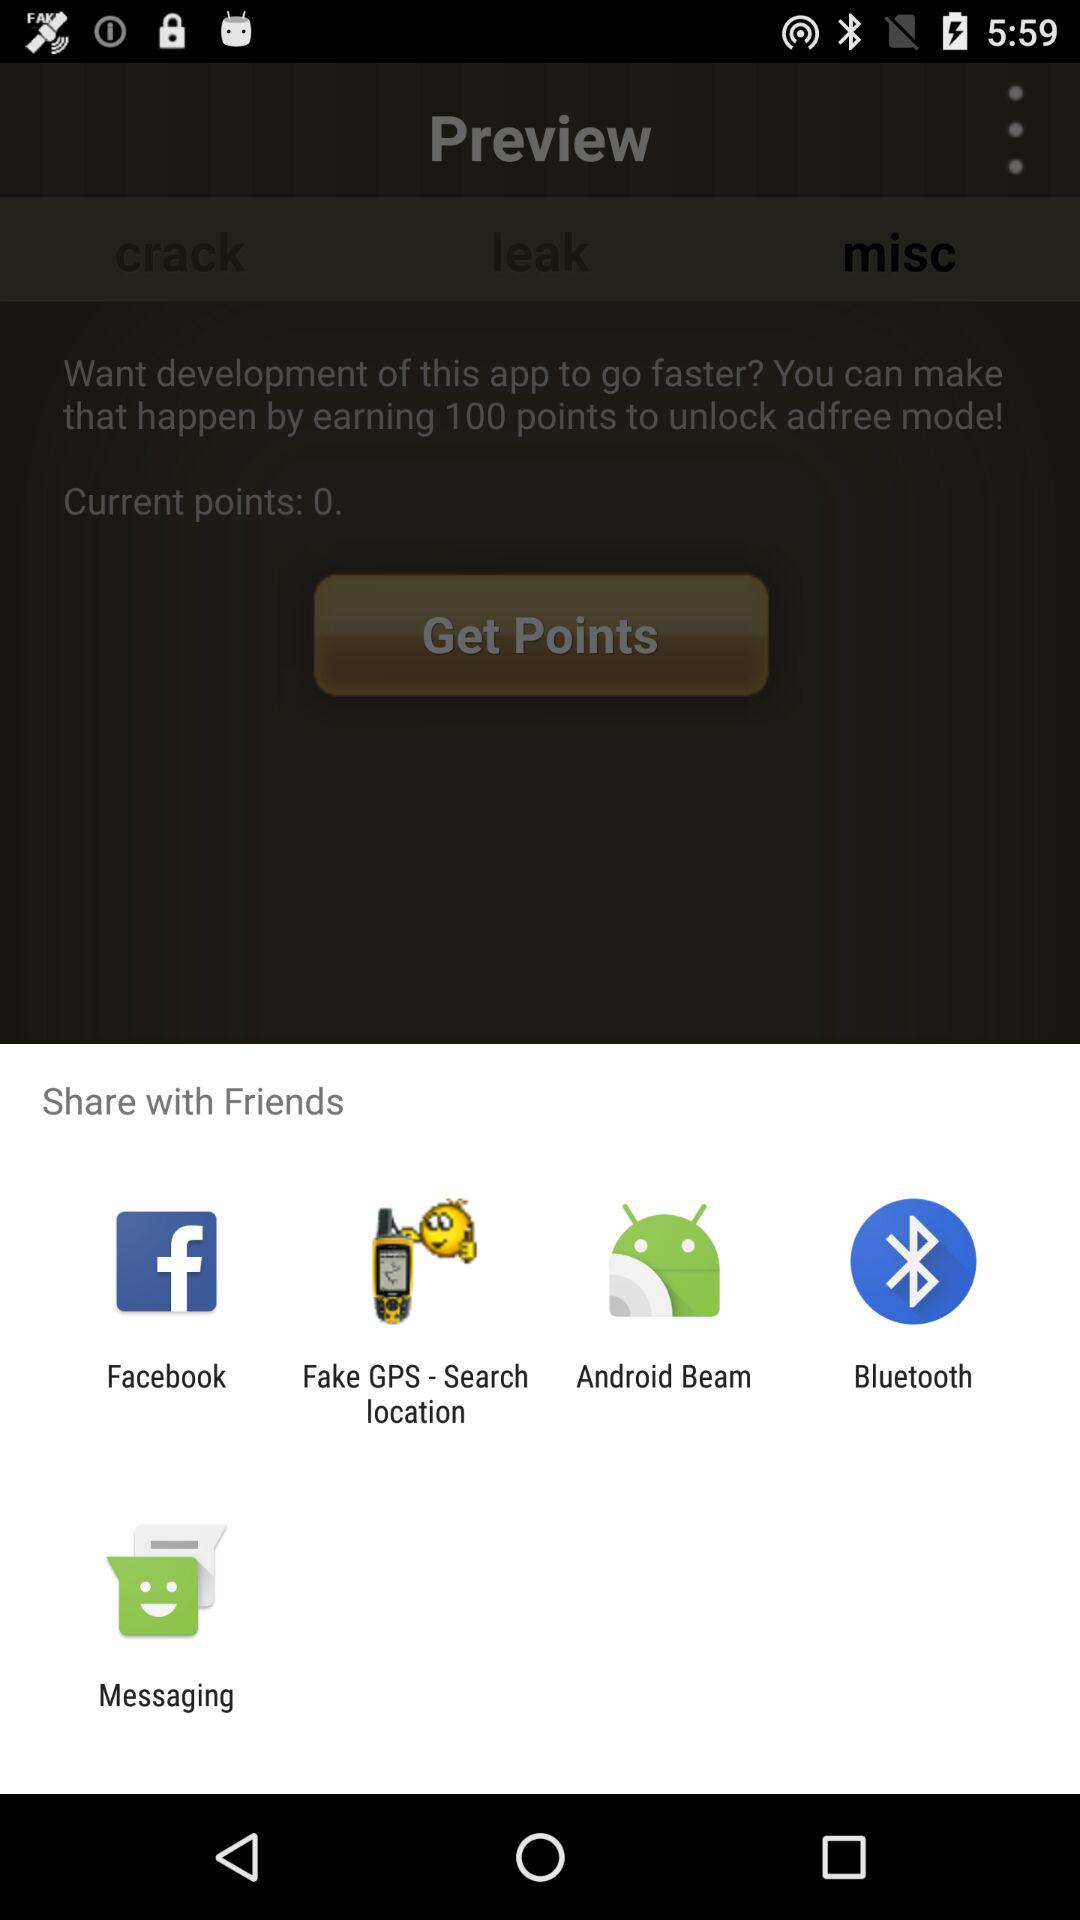How many more points are needed to unlock adfree mode?
Answer the question using a single word or phrase. 100 